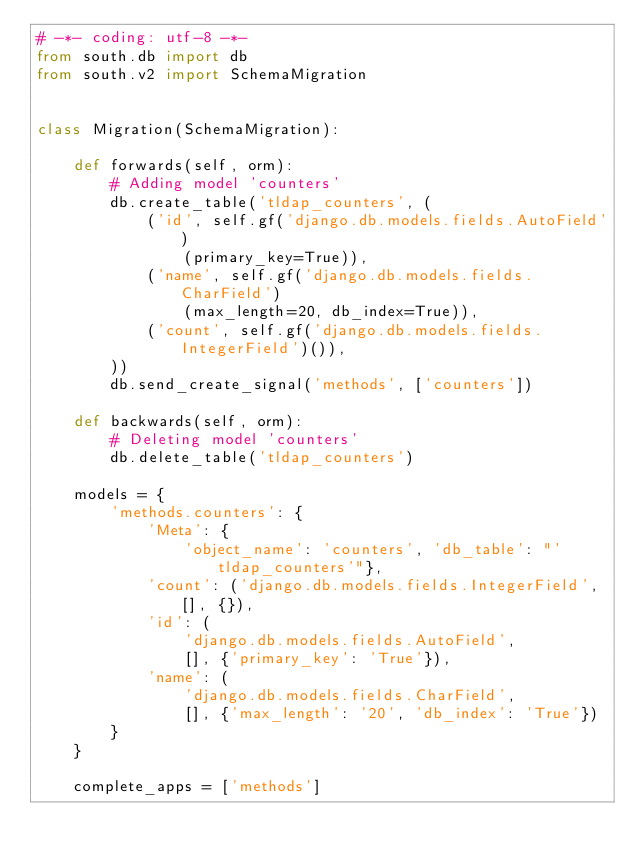<code> <loc_0><loc_0><loc_500><loc_500><_Python_># -*- coding: utf-8 -*-
from south.db import db
from south.v2 import SchemaMigration


class Migration(SchemaMigration):

    def forwards(self, orm):
        # Adding model 'counters'
        db.create_table('tldap_counters', (
            ('id', self.gf('django.db.models.fields.AutoField')
                (primary_key=True)),
            ('name', self.gf('django.db.models.fields.CharField')
                (max_length=20, db_index=True)),
            ('count', self.gf('django.db.models.fields.IntegerField')()),
        ))
        db.send_create_signal('methods', ['counters'])

    def backwards(self, orm):
        # Deleting model 'counters'
        db.delete_table('tldap_counters')

    models = {
        'methods.counters': {
            'Meta': {
                'object_name': 'counters', 'db_table': "'tldap_counters'"},
            'count': ('django.db.models.fields.IntegerField', [], {}),
            'id': (
                'django.db.models.fields.AutoField',
                [], {'primary_key': 'True'}),
            'name': (
                'django.db.models.fields.CharField',
                [], {'max_length': '20', 'db_index': 'True'})
        }
    }

    complete_apps = ['methods']
</code> 